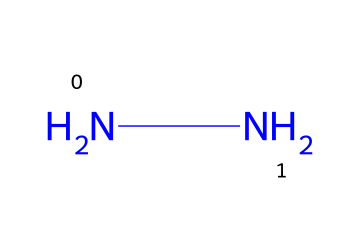What is the molecular formula of hydrazine? The SMILES representation "NN" indicates two nitrogen atoms connected by a single bond, implying a molecular formula of N2H4 (two nitrogen and four hydrogen atoms).
Answer: N2H4 How many nitrogen atoms are in hydrazine? Analyzing the SMILES "NN", it shows two nitrogen symbols, indicating there are 2 nitrogen atoms in the molecule.
Answer: 2 What type of bonds are present in hydrazine? The structure "NN" indicates a single bond between the two nitrogen atoms, representing a single bond type which is common in diatomic molecules.
Answer: single bond What is the oxidation state of nitrogen in hydrazine? In hydrazine, nitrogen is generally in the -2 oxidation state because each nitrogen atom forms bonds with hydrogen which is less electronegative, resulting in a reduction in its oxidation state.
Answer: -2 How many hydrogen atoms are bonded to nitrogen in hydrazine? Each nitrogen in hydrazine typically bonds with two hydrogen atoms, making a total of four hydrogen atoms (as inferred from the hydrazine structure).
Answer: 4 What is the primary use of hydrazine? Hydrazine is primarily used as a rocket fuel because of its high reactivity and energy content, making it suitable for propulsion applications.
Answer: rocket fuel Is hydrazine classified as a hazardous material? Yes, hydrazine is known to be toxic and is classified as a hazardous material due to its potential health effects and environmental dangers if improperly handled.
Answer: yes 